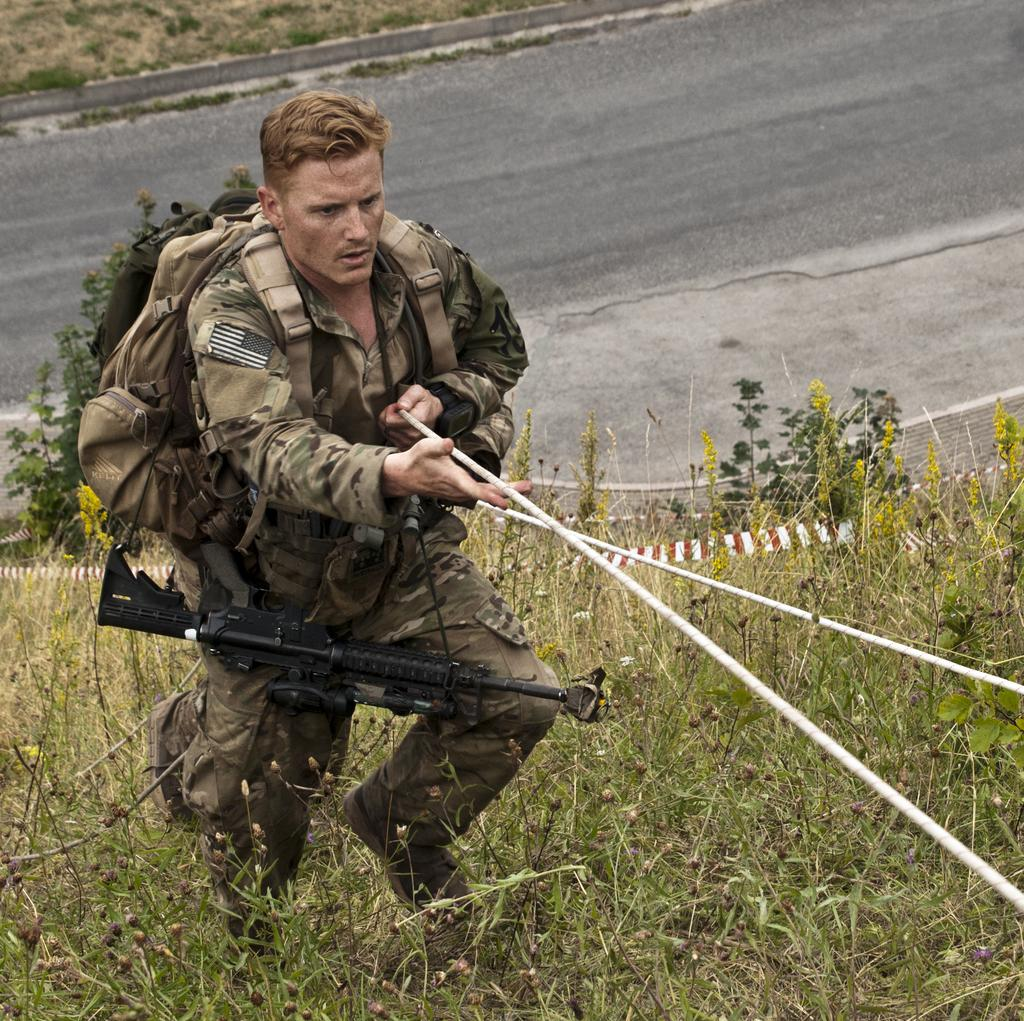What is present in the image? There is a person in the image. What is the person holding? The person is holding an object. What can be seen beneath the person's feet? The ground is visible in the image. What type of vegetation is present in the image? There is grass and plants in the image. What type of light can be seen in the middle of the image? There is no specific light source mentioned in the image, and the term "middle" is not relevant to the image's content. 